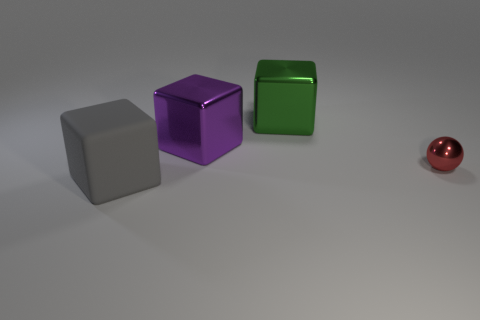What number of objects are either big objects that are on the right side of the gray block or purple metallic cylinders?
Make the answer very short. 2. Are there any gray rubber objects that are left of the large metal cube that is to the right of the large shiny cube that is in front of the green cube?
Give a very brief answer. Yes. Is the number of tiny red balls that are to the left of the small red thing less than the number of metal blocks in front of the big green cube?
Your response must be concise. Yes. There is another large cube that is the same material as the big green cube; what is its color?
Make the answer very short. Purple. The object in front of the metal thing right of the large green shiny object is what color?
Your answer should be very brief. Gray. Are there any big matte things that have the same color as the metallic sphere?
Offer a very short reply. No. There is a thing in front of the tiny red shiny ball; what number of big metallic blocks are on the left side of it?
Provide a short and direct response. 0. What number of other things are made of the same material as the tiny red sphere?
Ensure brevity in your answer.  2. The thing that is in front of the object on the right side of the green cube is what shape?
Your answer should be compact. Cube. There is a block in front of the sphere; what is its size?
Provide a short and direct response. Large. 